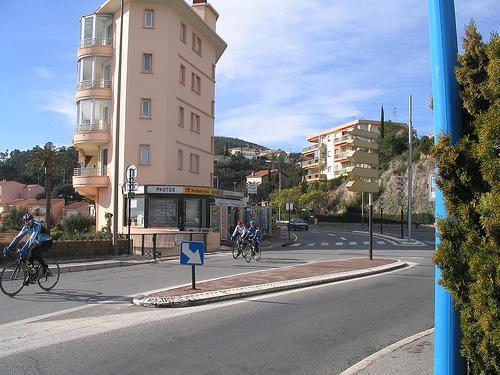How many lanes are on the other half of the road?
Give a very brief answer. 2. How many cyclists are wearing red helmets?
Give a very brief answer. 1. 